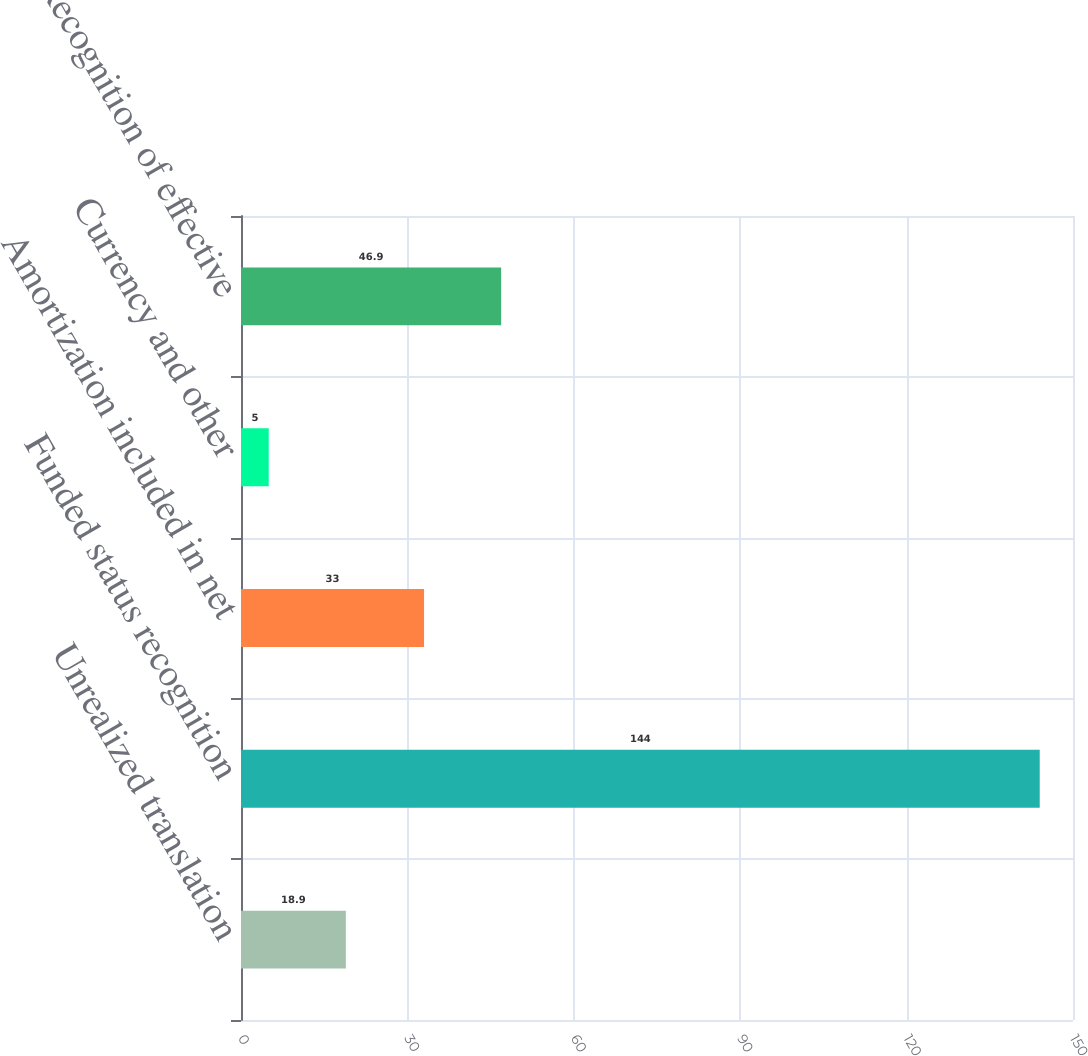<chart> <loc_0><loc_0><loc_500><loc_500><bar_chart><fcel>Unrealized translation<fcel>Funded status recognition<fcel>Amortization included in net<fcel>Currency and other<fcel>Recognition of effective<nl><fcel>18.9<fcel>144<fcel>33<fcel>5<fcel>46.9<nl></chart> 